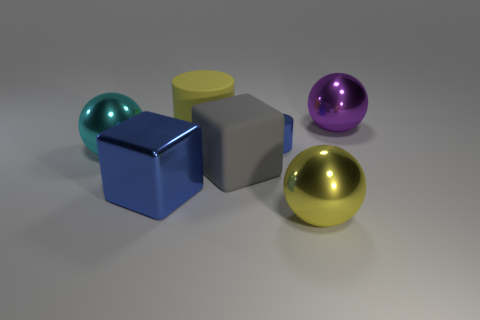Subtract all big yellow balls. How many balls are left? 2 Add 3 big red matte spheres. How many objects exist? 10 Subtract all spheres. How many objects are left? 4 Subtract 0 gray spheres. How many objects are left? 7 Subtract all yellow metal balls. Subtract all big purple shiny objects. How many objects are left? 5 Add 2 big cyan shiny balls. How many big cyan shiny balls are left? 3 Add 3 tiny gray spheres. How many tiny gray spheres exist? 3 